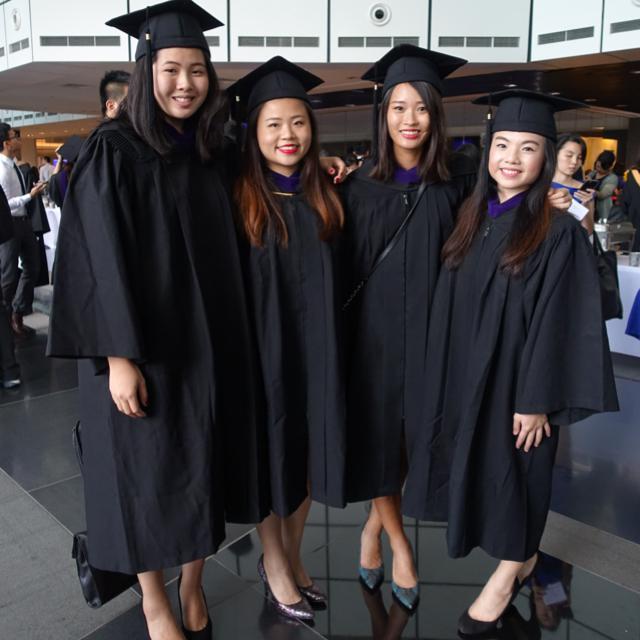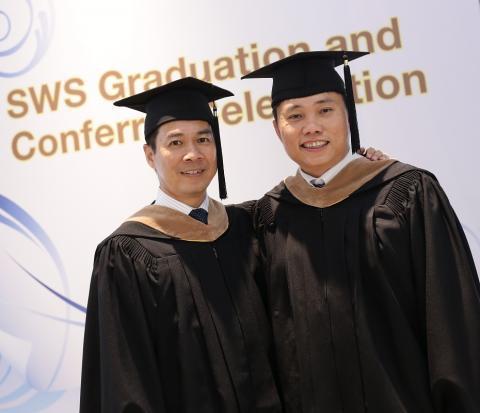The first image is the image on the left, the second image is the image on the right. Considering the images on both sides, is "There are at least five people in total." valid? Answer yes or no. Yes. The first image is the image on the left, the second image is the image on the right. Considering the images on both sides, is "There are atleast 5 people total" valid? Answer yes or no. Yes. 